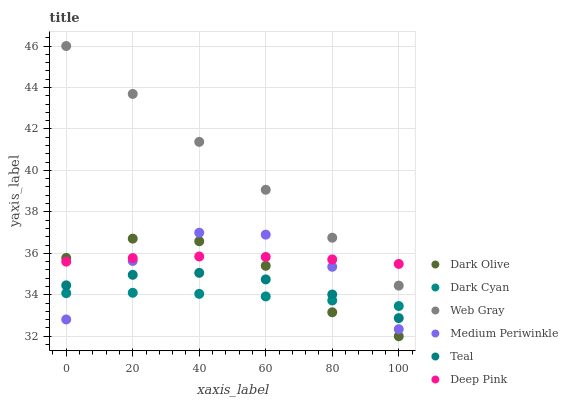Does Dark Cyan have the minimum area under the curve?
Answer yes or no. Yes. Does Web Gray have the maximum area under the curve?
Answer yes or no. Yes. Does Dark Olive have the minimum area under the curve?
Answer yes or no. No. Does Dark Olive have the maximum area under the curve?
Answer yes or no. No. Is Web Gray the smoothest?
Answer yes or no. Yes. Is Medium Periwinkle the roughest?
Answer yes or no. Yes. Is Dark Olive the smoothest?
Answer yes or no. No. Is Dark Olive the roughest?
Answer yes or no. No. Does Dark Olive have the lowest value?
Answer yes or no. Yes. Does Medium Periwinkle have the lowest value?
Answer yes or no. No. Does Web Gray have the highest value?
Answer yes or no. Yes. Does Dark Olive have the highest value?
Answer yes or no. No. Is Dark Cyan less than Deep Pink?
Answer yes or no. Yes. Is Web Gray greater than Dark Olive?
Answer yes or no. Yes. Does Dark Cyan intersect Medium Periwinkle?
Answer yes or no. Yes. Is Dark Cyan less than Medium Periwinkle?
Answer yes or no. No. Is Dark Cyan greater than Medium Periwinkle?
Answer yes or no. No. Does Dark Cyan intersect Deep Pink?
Answer yes or no. No. 